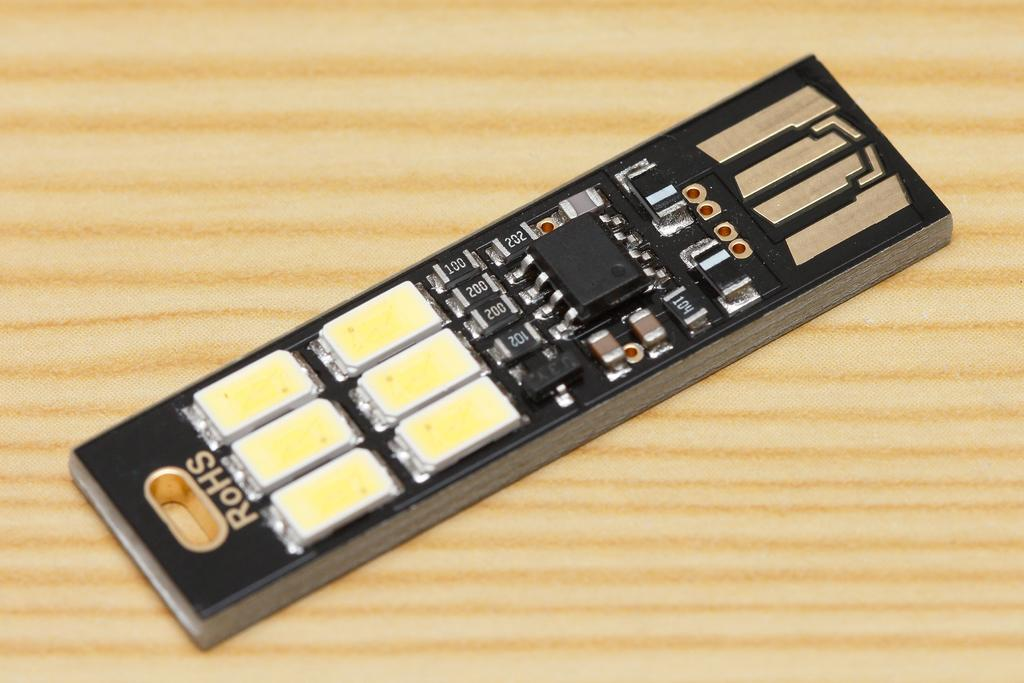<image>
Provide a brief description of the given image. A small electronic component has the word RoHS on the top. 